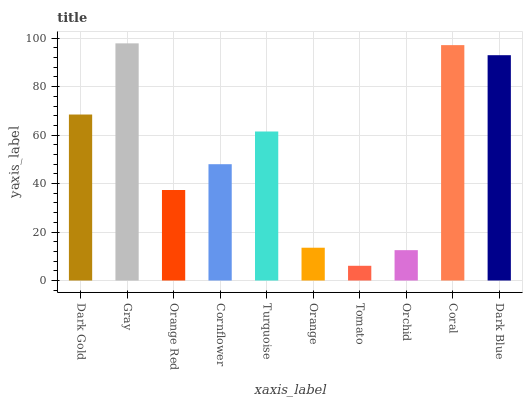Is Tomato the minimum?
Answer yes or no. Yes. Is Gray the maximum?
Answer yes or no. Yes. Is Orange Red the minimum?
Answer yes or no. No. Is Orange Red the maximum?
Answer yes or no. No. Is Gray greater than Orange Red?
Answer yes or no. Yes. Is Orange Red less than Gray?
Answer yes or no. Yes. Is Orange Red greater than Gray?
Answer yes or no. No. Is Gray less than Orange Red?
Answer yes or no. No. Is Turquoise the high median?
Answer yes or no. Yes. Is Cornflower the low median?
Answer yes or no. Yes. Is Orchid the high median?
Answer yes or no. No. Is Orange the low median?
Answer yes or no. No. 